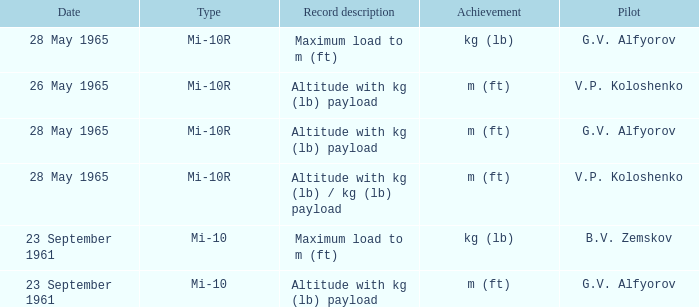Pilot of g.v. alfyorov, and a Record description of altitude with kg (lb) payload, and a Type of mi-10 involved what date? 23 September 1961. 